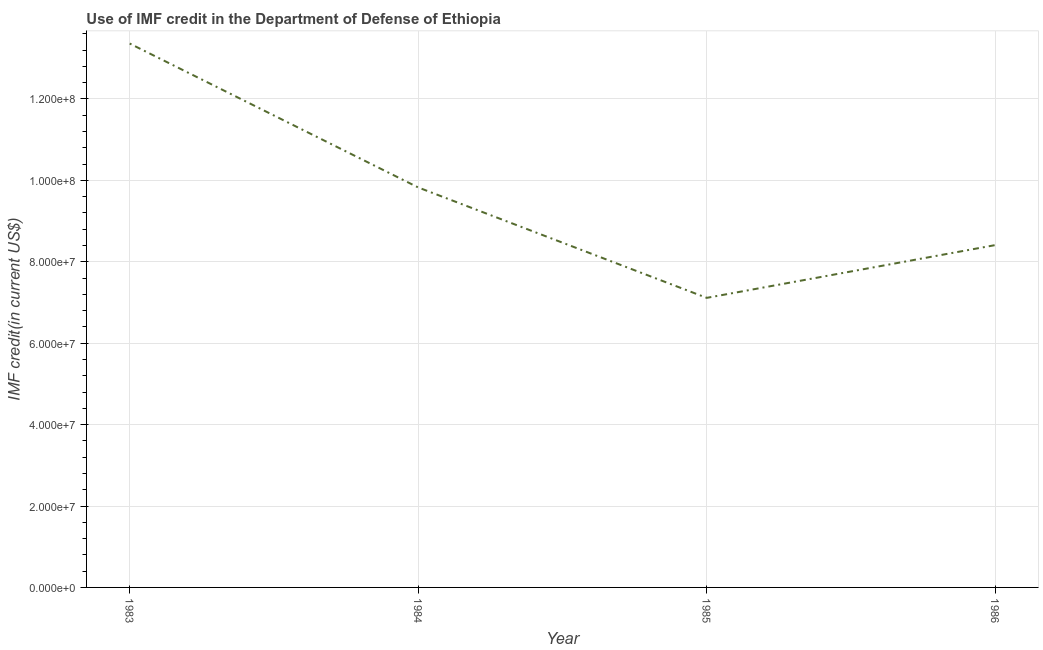What is the use of imf credit in dod in 1984?
Provide a short and direct response. 9.83e+07. Across all years, what is the maximum use of imf credit in dod?
Your answer should be very brief. 1.34e+08. Across all years, what is the minimum use of imf credit in dod?
Your answer should be very brief. 7.11e+07. In which year was the use of imf credit in dod minimum?
Your answer should be very brief. 1985. What is the sum of the use of imf credit in dod?
Offer a terse response. 3.87e+08. What is the difference between the use of imf credit in dod in 1984 and 1985?
Make the answer very short. 2.71e+07. What is the average use of imf credit in dod per year?
Keep it short and to the point. 9.68e+07. What is the median use of imf credit in dod?
Your answer should be compact. 9.12e+07. In how many years, is the use of imf credit in dod greater than 120000000 US$?
Make the answer very short. 1. Do a majority of the years between 1985 and 1983 (inclusive) have use of imf credit in dod greater than 84000000 US$?
Keep it short and to the point. No. What is the ratio of the use of imf credit in dod in 1984 to that in 1985?
Provide a succinct answer. 1.38. Is the difference between the use of imf credit in dod in 1983 and 1985 greater than the difference between any two years?
Offer a terse response. Yes. What is the difference between the highest and the second highest use of imf credit in dod?
Make the answer very short. 3.54e+07. What is the difference between the highest and the lowest use of imf credit in dod?
Give a very brief answer. 6.25e+07. In how many years, is the use of imf credit in dod greater than the average use of imf credit in dod taken over all years?
Your answer should be very brief. 2. How many lines are there?
Keep it short and to the point. 1. How many years are there in the graph?
Provide a short and direct response. 4. Does the graph contain any zero values?
Provide a short and direct response. No. What is the title of the graph?
Give a very brief answer. Use of IMF credit in the Department of Defense of Ethiopia. What is the label or title of the X-axis?
Make the answer very short. Year. What is the label or title of the Y-axis?
Provide a short and direct response. IMF credit(in current US$). What is the IMF credit(in current US$) in 1983?
Your answer should be compact. 1.34e+08. What is the IMF credit(in current US$) of 1984?
Keep it short and to the point. 9.83e+07. What is the IMF credit(in current US$) of 1985?
Provide a short and direct response. 7.11e+07. What is the IMF credit(in current US$) of 1986?
Provide a short and direct response. 8.41e+07. What is the difference between the IMF credit(in current US$) in 1983 and 1984?
Your answer should be very brief. 3.54e+07. What is the difference between the IMF credit(in current US$) in 1983 and 1985?
Provide a succinct answer. 6.25e+07. What is the difference between the IMF credit(in current US$) in 1983 and 1986?
Give a very brief answer. 4.95e+07. What is the difference between the IMF credit(in current US$) in 1984 and 1985?
Offer a very short reply. 2.71e+07. What is the difference between the IMF credit(in current US$) in 1984 and 1986?
Your answer should be compact. 1.42e+07. What is the difference between the IMF credit(in current US$) in 1985 and 1986?
Your response must be concise. -1.30e+07. What is the ratio of the IMF credit(in current US$) in 1983 to that in 1984?
Give a very brief answer. 1.36. What is the ratio of the IMF credit(in current US$) in 1983 to that in 1985?
Offer a terse response. 1.88. What is the ratio of the IMF credit(in current US$) in 1983 to that in 1986?
Ensure brevity in your answer.  1.59. What is the ratio of the IMF credit(in current US$) in 1984 to that in 1985?
Offer a terse response. 1.38. What is the ratio of the IMF credit(in current US$) in 1984 to that in 1986?
Provide a short and direct response. 1.17. What is the ratio of the IMF credit(in current US$) in 1985 to that in 1986?
Offer a terse response. 0.85. 